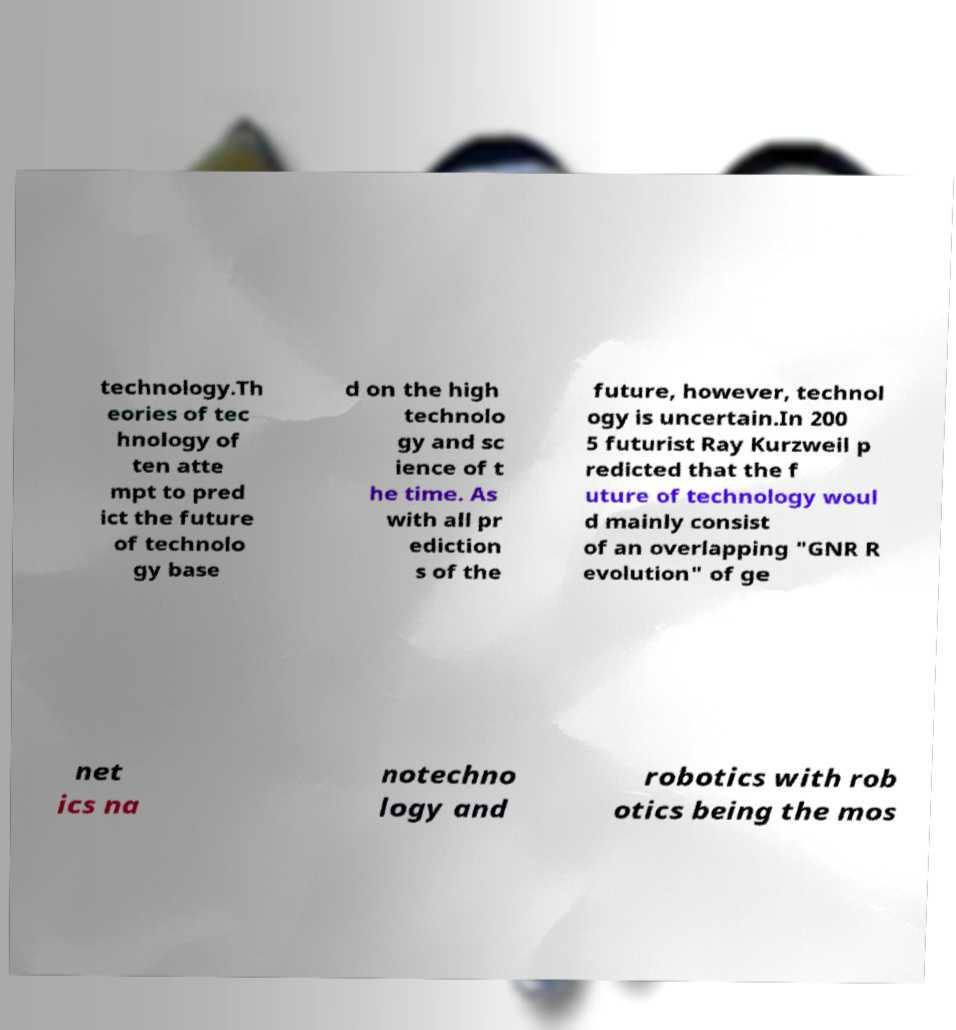Can you read and provide the text displayed in the image?This photo seems to have some interesting text. Can you extract and type it out for me? technology.Th eories of tec hnology of ten atte mpt to pred ict the future of technolo gy base d on the high technolo gy and sc ience of t he time. As with all pr ediction s of the future, however, technol ogy is uncertain.In 200 5 futurist Ray Kurzweil p redicted that the f uture of technology woul d mainly consist of an overlapping "GNR R evolution" of ge net ics na notechno logy and robotics with rob otics being the mos 